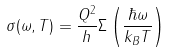Convert formula to latex. <formula><loc_0><loc_0><loc_500><loc_500>\sigma ( \omega , T ) = \frac { Q ^ { 2 } } { h } \Sigma \left ( \frac { \hbar { \omega } } { k _ { B } T } \right )</formula> 